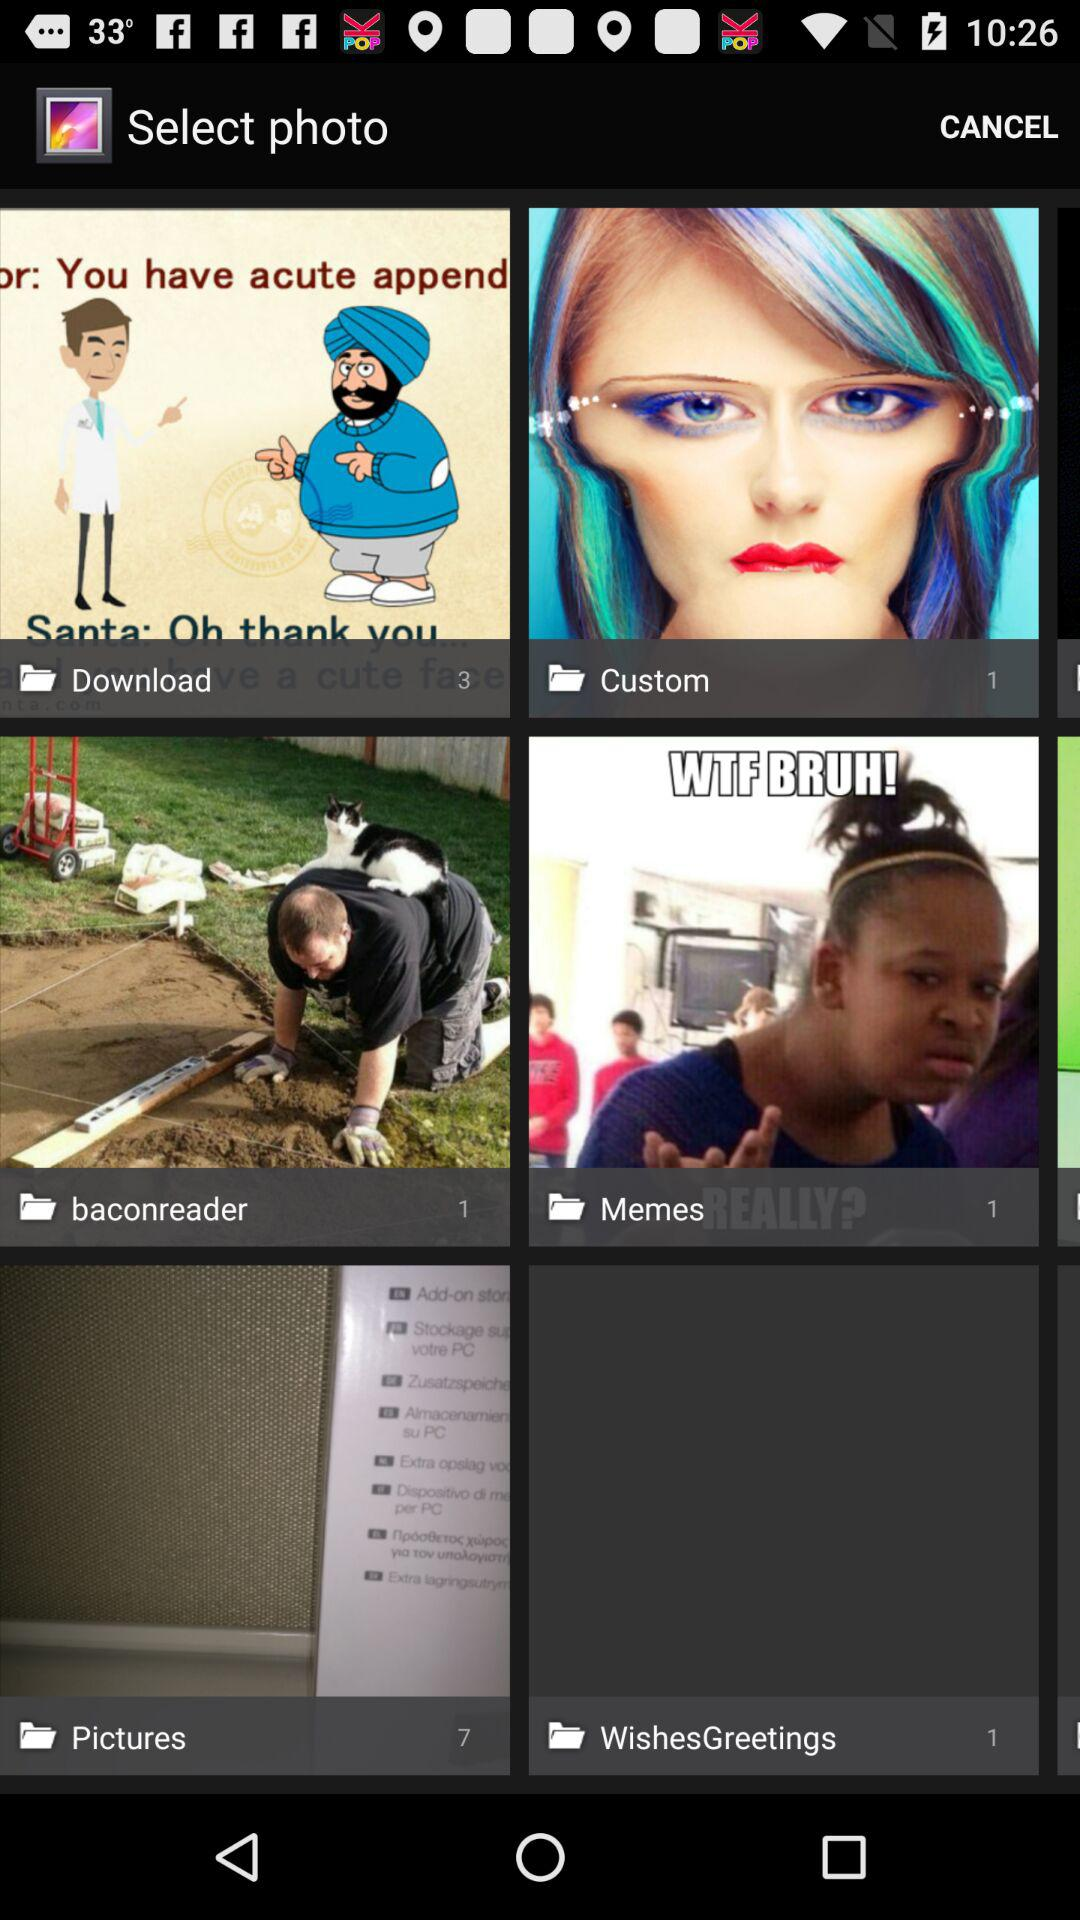How many pictures are in the Download folder? There are 3 pictures. 